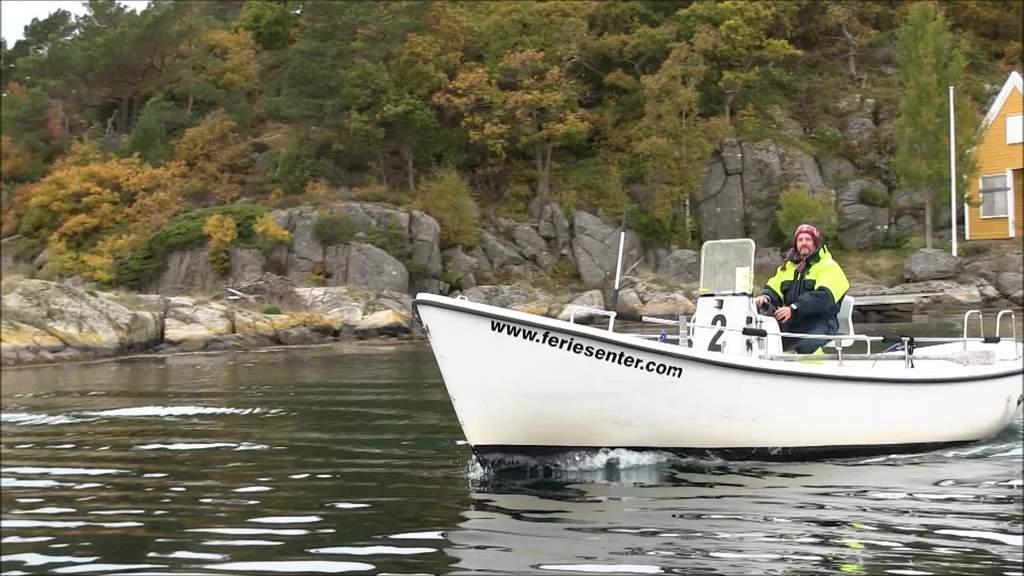How would you summarize this image in a sentence or two? In this image there is a person wearing a high-wiz jacket is riding a motor boat on the water, in the background of the image there are trees and rocks. 